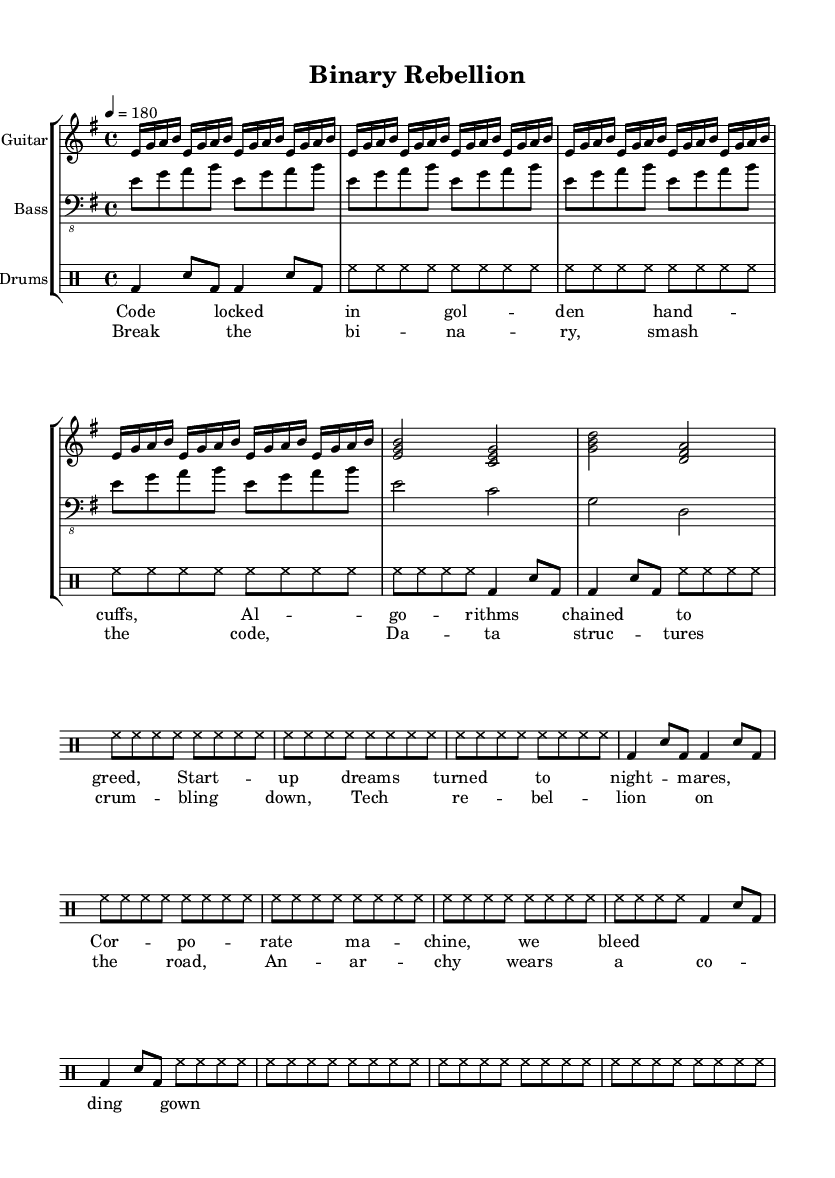What is the key signature of this music? The key signature is indicated at the beginning of the piece. The music is in E minor, which has one sharp.
Answer: E minor What is the time signature of this music? The time signature is found at the beginning of the score. It is in 4/4 time.
Answer: 4/4 What is the tempo marking for this piece? The tempo marking is stated at the beginning of the score, indicating how fast the music should be played. It says quarter note equals 180 beats per minute.
Answer: 180 How many measures are there in the guitar part? To find the number of measures, we can count each distinct grouping of the musical notes in the guitar part. There are a total of 11 measures.
Answer: 11 What are the lyrics for the chorus? The lyrics for the chorus are provided in the lyric mode section. They read: "Break the binary, smash the code, Data structures crumbling down, Tech rebellion on the road, Anarchy wears a coding gown."
Answer: Break the binary, smash the code, Data structures crumbling down, Tech rebellion on the road, Anarchy wears a coding gown How does the bass line relate to the guitar part? To examine the relationship, we can look at how both parts play together musically. The bass line follows a simple progression that complements the guitar riff, often playing the root notes of the chords provided in the guitar part.
Answer: It complements the guitar 